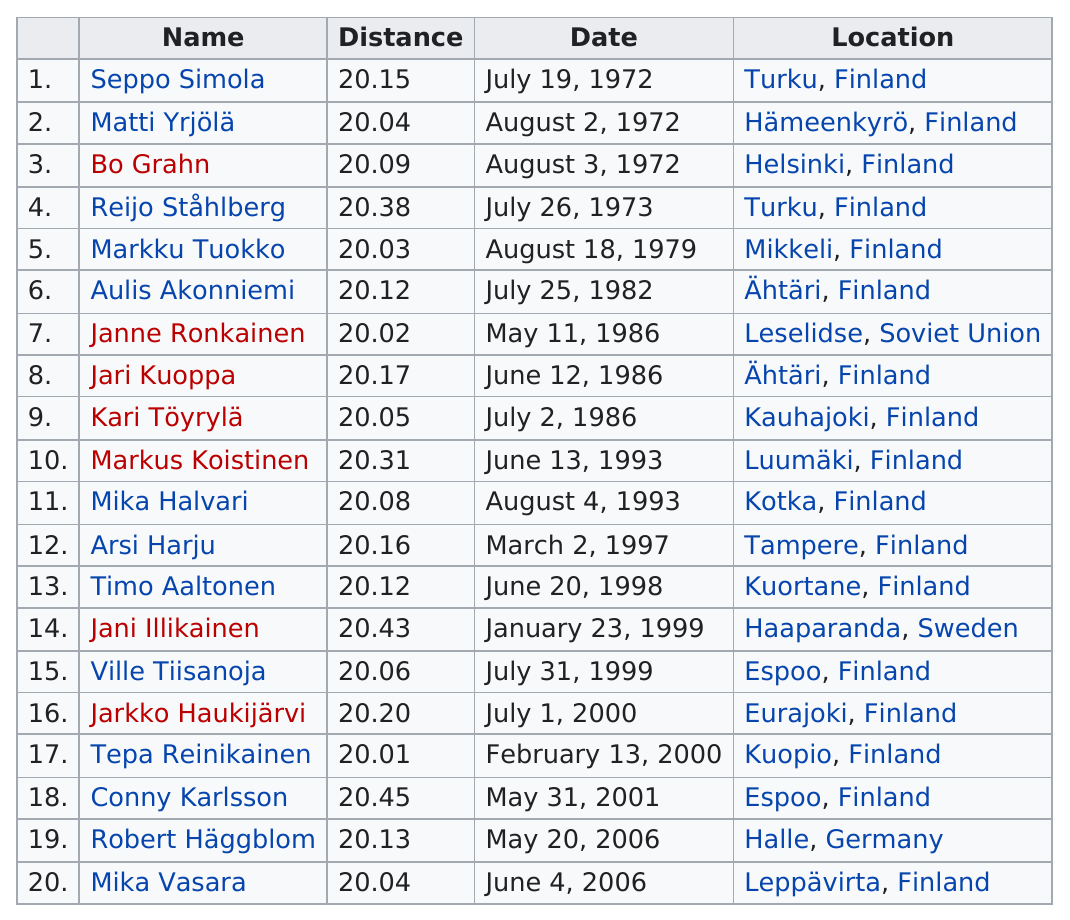Point out several critical features in this image. Jari Kuoppa had the farther distance recorded, compared to Arsi Harju. The club member with the farthest shot put is Conny Karlsson. Mika Vasara was the last member to join the 20 metre club. Robert Häggblom is the only person since 2000 to have joined the 20 metre club at an event outside Finland. Eight club members were able to put the shot at least 20.15 meters on their first attempt to break 20 meters. 